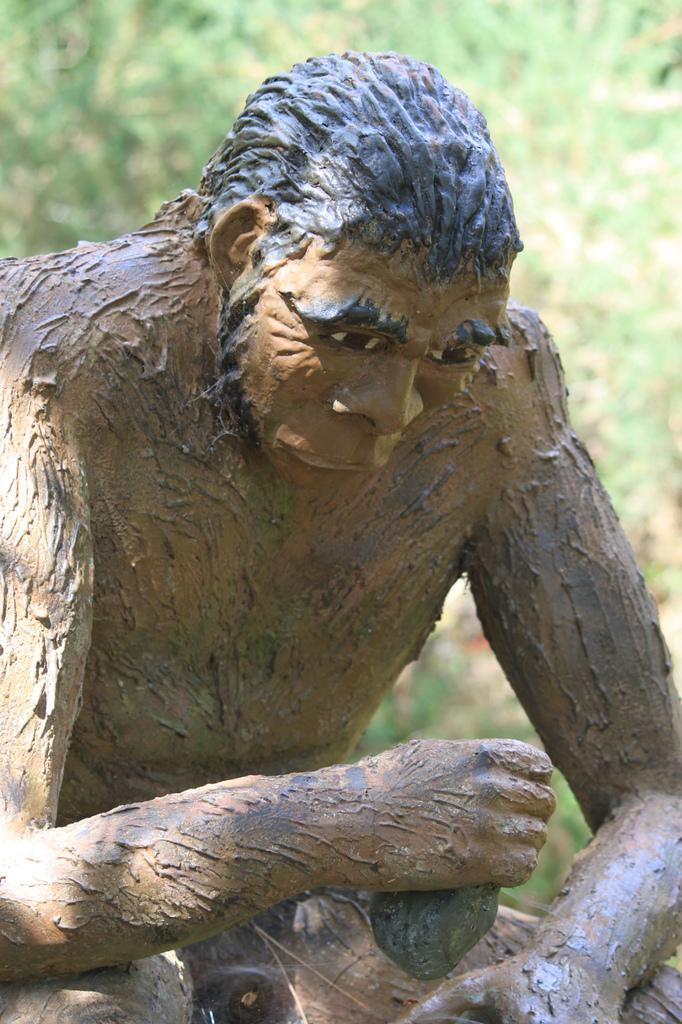Describe this image in one or two sentences. In this image we can see the statue of an ape man. The background of the image is slightly blurred, where we can see trees. 